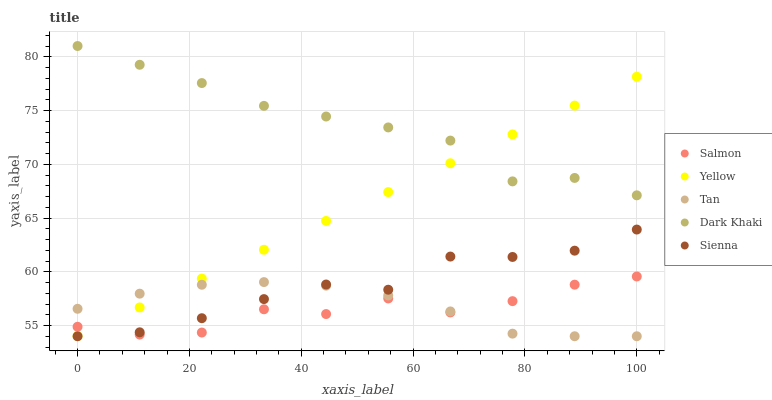Does Salmon have the minimum area under the curve?
Answer yes or no. Yes. Does Dark Khaki have the maximum area under the curve?
Answer yes or no. Yes. Does Sienna have the minimum area under the curve?
Answer yes or no. No. Does Sienna have the maximum area under the curve?
Answer yes or no. No. Is Yellow the smoothest?
Answer yes or no. Yes. Is Salmon the roughest?
Answer yes or no. Yes. Is Sienna the smoothest?
Answer yes or no. No. Is Sienna the roughest?
Answer yes or no. No. Does Sienna have the lowest value?
Answer yes or no. Yes. Does Salmon have the lowest value?
Answer yes or no. No. Does Dark Khaki have the highest value?
Answer yes or no. Yes. Does Sienna have the highest value?
Answer yes or no. No. Is Sienna less than Dark Khaki?
Answer yes or no. Yes. Is Dark Khaki greater than Salmon?
Answer yes or no. Yes. Does Yellow intersect Tan?
Answer yes or no. Yes. Is Yellow less than Tan?
Answer yes or no. No. Is Yellow greater than Tan?
Answer yes or no. No. Does Sienna intersect Dark Khaki?
Answer yes or no. No. 